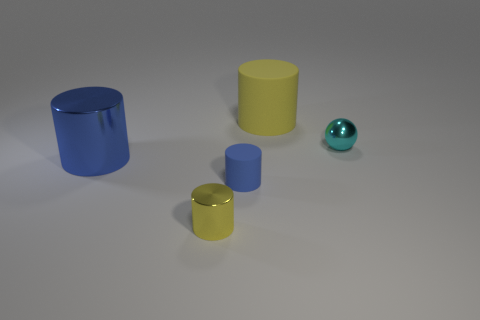Can you tell me the different shapes present in the image? Certainly, the image features cylindrical shapes in various sizes and a single spherical shape. 